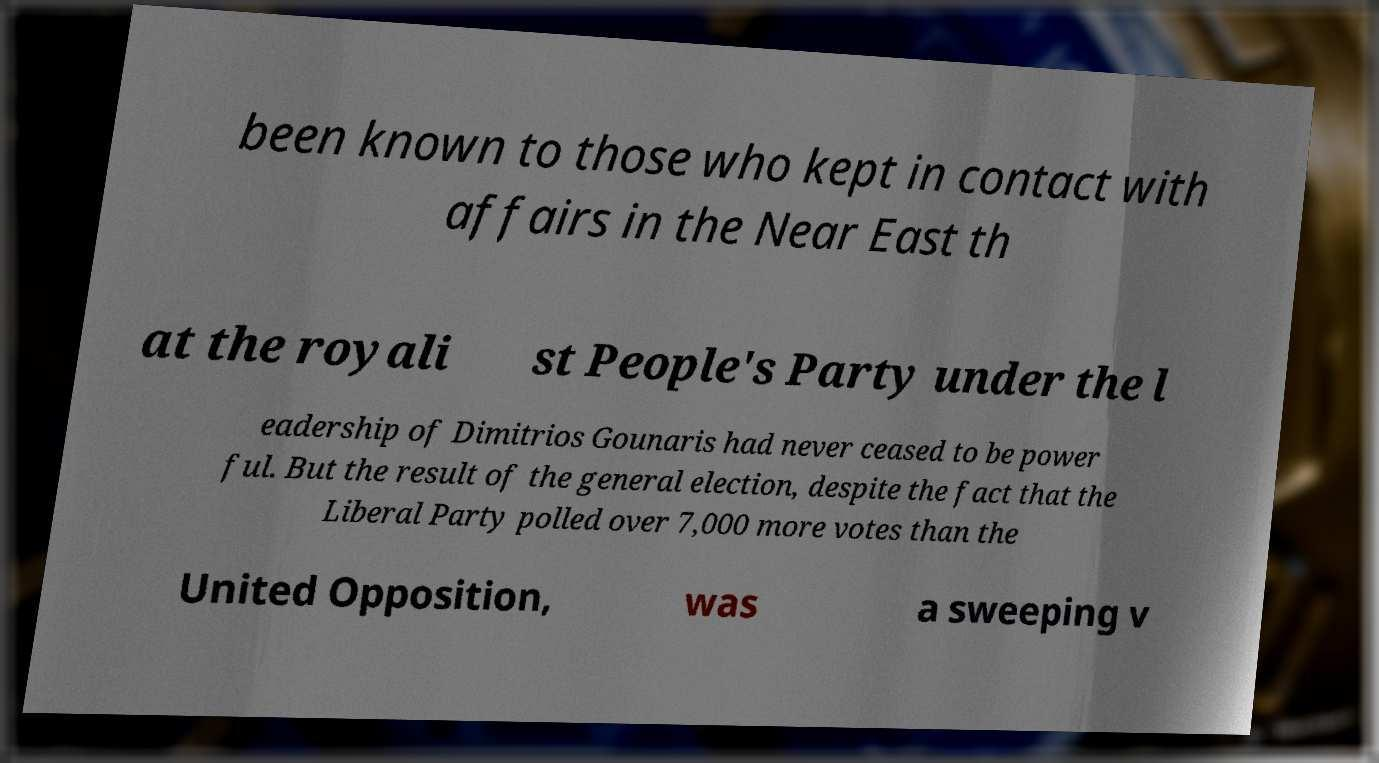Please identify and transcribe the text found in this image. been known to those who kept in contact with affairs in the Near East th at the royali st People's Party under the l eadership of Dimitrios Gounaris had never ceased to be power ful. But the result of the general election, despite the fact that the Liberal Party polled over 7,000 more votes than the United Opposition, was a sweeping v 